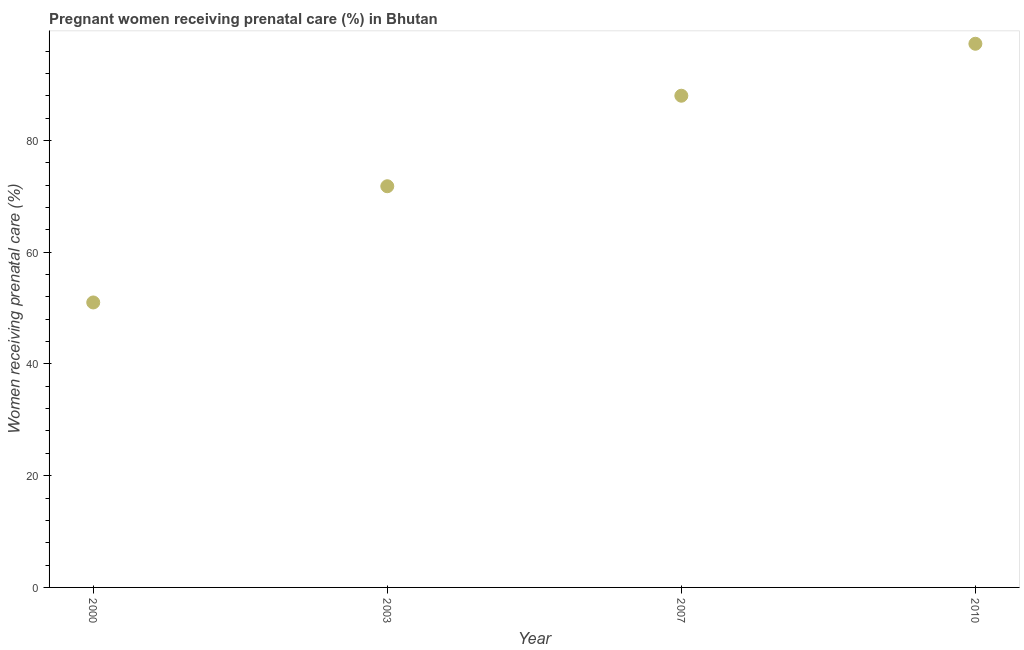What is the percentage of pregnant women receiving prenatal care in 2007?
Ensure brevity in your answer.  88. Across all years, what is the maximum percentage of pregnant women receiving prenatal care?
Ensure brevity in your answer.  97.3. What is the sum of the percentage of pregnant women receiving prenatal care?
Offer a terse response. 308.1. What is the difference between the percentage of pregnant women receiving prenatal care in 2003 and 2007?
Give a very brief answer. -16.2. What is the average percentage of pregnant women receiving prenatal care per year?
Make the answer very short. 77.03. What is the median percentage of pregnant women receiving prenatal care?
Offer a terse response. 79.9. Do a majority of the years between 2000 and 2007 (inclusive) have percentage of pregnant women receiving prenatal care greater than 36 %?
Keep it short and to the point. Yes. What is the ratio of the percentage of pregnant women receiving prenatal care in 2000 to that in 2007?
Your answer should be compact. 0.58. Is the percentage of pregnant women receiving prenatal care in 2003 less than that in 2007?
Keep it short and to the point. Yes. Is the difference between the percentage of pregnant women receiving prenatal care in 2000 and 2007 greater than the difference between any two years?
Provide a succinct answer. No. What is the difference between the highest and the second highest percentage of pregnant women receiving prenatal care?
Offer a terse response. 9.3. Is the sum of the percentage of pregnant women receiving prenatal care in 2007 and 2010 greater than the maximum percentage of pregnant women receiving prenatal care across all years?
Keep it short and to the point. Yes. What is the difference between the highest and the lowest percentage of pregnant women receiving prenatal care?
Offer a very short reply. 46.3. How many years are there in the graph?
Your answer should be compact. 4. Are the values on the major ticks of Y-axis written in scientific E-notation?
Provide a succinct answer. No. Does the graph contain any zero values?
Keep it short and to the point. No. What is the title of the graph?
Keep it short and to the point. Pregnant women receiving prenatal care (%) in Bhutan. What is the label or title of the Y-axis?
Make the answer very short. Women receiving prenatal care (%). What is the Women receiving prenatal care (%) in 2003?
Your answer should be compact. 71.8. What is the Women receiving prenatal care (%) in 2007?
Your response must be concise. 88. What is the Women receiving prenatal care (%) in 2010?
Your answer should be compact. 97.3. What is the difference between the Women receiving prenatal care (%) in 2000 and 2003?
Offer a terse response. -20.8. What is the difference between the Women receiving prenatal care (%) in 2000 and 2007?
Provide a succinct answer. -37. What is the difference between the Women receiving prenatal care (%) in 2000 and 2010?
Give a very brief answer. -46.3. What is the difference between the Women receiving prenatal care (%) in 2003 and 2007?
Provide a succinct answer. -16.2. What is the difference between the Women receiving prenatal care (%) in 2003 and 2010?
Ensure brevity in your answer.  -25.5. What is the ratio of the Women receiving prenatal care (%) in 2000 to that in 2003?
Keep it short and to the point. 0.71. What is the ratio of the Women receiving prenatal care (%) in 2000 to that in 2007?
Your response must be concise. 0.58. What is the ratio of the Women receiving prenatal care (%) in 2000 to that in 2010?
Give a very brief answer. 0.52. What is the ratio of the Women receiving prenatal care (%) in 2003 to that in 2007?
Make the answer very short. 0.82. What is the ratio of the Women receiving prenatal care (%) in 2003 to that in 2010?
Offer a very short reply. 0.74. What is the ratio of the Women receiving prenatal care (%) in 2007 to that in 2010?
Provide a succinct answer. 0.9. 